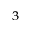<formula> <loc_0><loc_0><loc_500><loc_500>_ { 3 }</formula> 